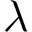Convert formula to latex. <formula><loc_0><loc_0><loc_500><loc_500>\lambda</formula> 